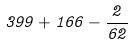<formula> <loc_0><loc_0><loc_500><loc_500>3 9 9 + 1 6 6 - \frac { 2 } { 6 2 }</formula> 